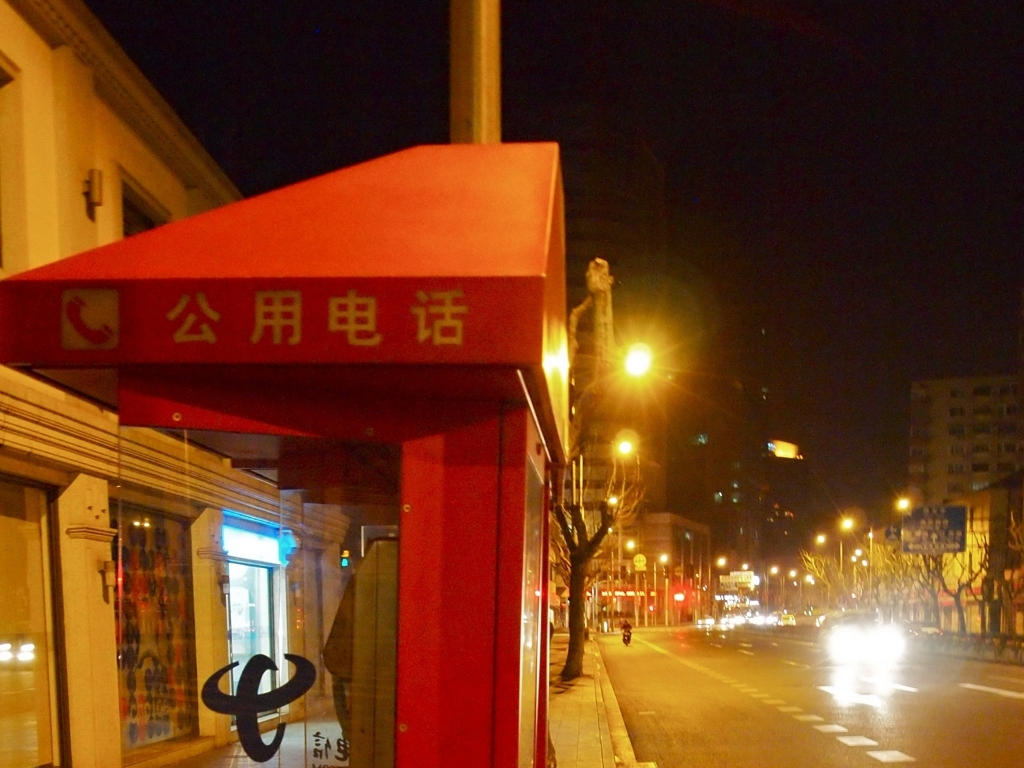Can you tell what time of day it is based on the lighting in the image? The photo is taken at night, as evidenced by the artificial street lighting and the lack of natural light. The sky is dark, and the shop appears closed, which typically indicates after-business hours. 